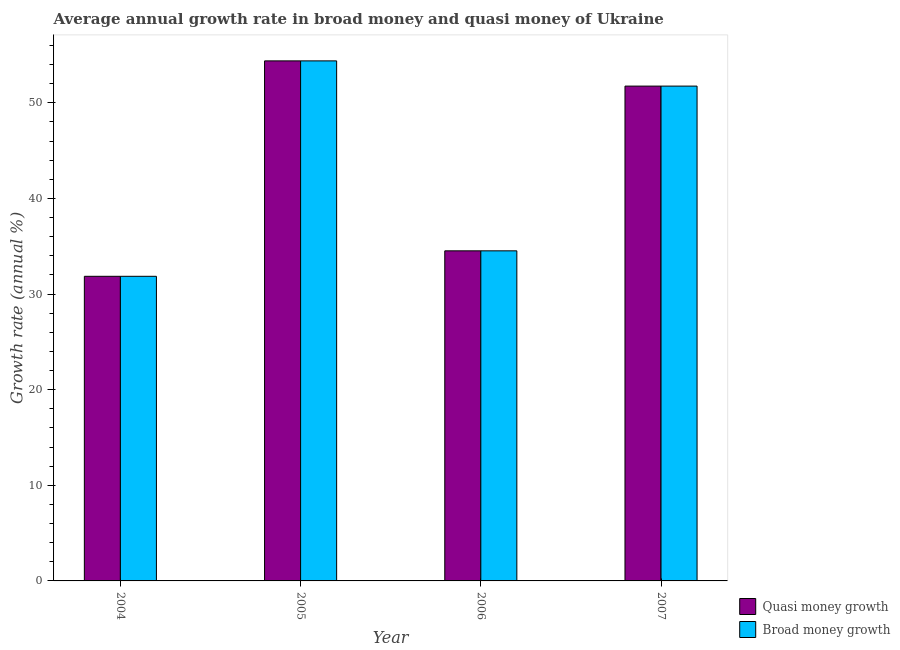How many different coloured bars are there?
Ensure brevity in your answer.  2. How many groups of bars are there?
Provide a short and direct response. 4. What is the label of the 1st group of bars from the left?
Offer a terse response. 2004. In how many cases, is the number of bars for a given year not equal to the number of legend labels?
Make the answer very short. 0. What is the annual growth rate in broad money in 2006?
Offer a terse response. 34.52. Across all years, what is the maximum annual growth rate in quasi money?
Make the answer very short. 54.39. Across all years, what is the minimum annual growth rate in quasi money?
Offer a terse response. 31.86. In which year was the annual growth rate in broad money maximum?
Keep it short and to the point. 2005. In which year was the annual growth rate in quasi money minimum?
Your response must be concise. 2004. What is the total annual growth rate in quasi money in the graph?
Make the answer very short. 172.51. What is the difference between the annual growth rate in broad money in 2005 and that in 2006?
Offer a very short reply. 19.87. What is the difference between the annual growth rate in quasi money in 2005 and the annual growth rate in broad money in 2006?
Offer a terse response. 19.87. What is the average annual growth rate in quasi money per year?
Offer a terse response. 43.13. In the year 2005, what is the difference between the annual growth rate in broad money and annual growth rate in quasi money?
Your answer should be compact. 0. In how many years, is the annual growth rate in broad money greater than 26 %?
Ensure brevity in your answer.  4. What is the ratio of the annual growth rate in broad money in 2005 to that in 2007?
Your answer should be very brief. 1.05. What is the difference between the highest and the second highest annual growth rate in quasi money?
Provide a short and direct response. 2.64. What is the difference between the highest and the lowest annual growth rate in quasi money?
Ensure brevity in your answer.  22.53. In how many years, is the annual growth rate in quasi money greater than the average annual growth rate in quasi money taken over all years?
Provide a short and direct response. 2. What does the 1st bar from the left in 2005 represents?
Make the answer very short. Quasi money growth. What does the 1st bar from the right in 2007 represents?
Offer a very short reply. Broad money growth. How many bars are there?
Your answer should be very brief. 8. Are all the bars in the graph horizontal?
Make the answer very short. No. How many years are there in the graph?
Provide a short and direct response. 4. Are the values on the major ticks of Y-axis written in scientific E-notation?
Provide a short and direct response. No. Where does the legend appear in the graph?
Make the answer very short. Bottom right. How are the legend labels stacked?
Keep it short and to the point. Vertical. What is the title of the graph?
Your answer should be very brief. Average annual growth rate in broad money and quasi money of Ukraine. Does "Transport services" appear as one of the legend labels in the graph?
Your response must be concise. No. What is the label or title of the Y-axis?
Your answer should be compact. Growth rate (annual %). What is the Growth rate (annual %) of Quasi money growth in 2004?
Offer a terse response. 31.86. What is the Growth rate (annual %) in Broad money growth in 2004?
Your answer should be very brief. 31.86. What is the Growth rate (annual %) of Quasi money growth in 2005?
Give a very brief answer. 54.39. What is the Growth rate (annual %) in Broad money growth in 2005?
Your answer should be very brief. 54.39. What is the Growth rate (annual %) in Quasi money growth in 2006?
Keep it short and to the point. 34.52. What is the Growth rate (annual %) of Broad money growth in 2006?
Give a very brief answer. 34.52. What is the Growth rate (annual %) of Quasi money growth in 2007?
Ensure brevity in your answer.  51.75. What is the Growth rate (annual %) in Broad money growth in 2007?
Offer a terse response. 51.75. Across all years, what is the maximum Growth rate (annual %) in Quasi money growth?
Your response must be concise. 54.39. Across all years, what is the maximum Growth rate (annual %) in Broad money growth?
Make the answer very short. 54.39. Across all years, what is the minimum Growth rate (annual %) in Quasi money growth?
Provide a succinct answer. 31.86. Across all years, what is the minimum Growth rate (annual %) of Broad money growth?
Offer a very short reply. 31.86. What is the total Growth rate (annual %) in Quasi money growth in the graph?
Your response must be concise. 172.51. What is the total Growth rate (annual %) of Broad money growth in the graph?
Offer a very short reply. 172.51. What is the difference between the Growth rate (annual %) in Quasi money growth in 2004 and that in 2005?
Your answer should be very brief. -22.53. What is the difference between the Growth rate (annual %) in Broad money growth in 2004 and that in 2005?
Your answer should be compact. -22.53. What is the difference between the Growth rate (annual %) in Quasi money growth in 2004 and that in 2006?
Provide a short and direct response. -2.66. What is the difference between the Growth rate (annual %) of Broad money growth in 2004 and that in 2006?
Ensure brevity in your answer.  -2.66. What is the difference between the Growth rate (annual %) in Quasi money growth in 2004 and that in 2007?
Ensure brevity in your answer.  -19.89. What is the difference between the Growth rate (annual %) of Broad money growth in 2004 and that in 2007?
Ensure brevity in your answer.  -19.89. What is the difference between the Growth rate (annual %) in Quasi money growth in 2005 and that in 2006?
Your answer should be compact. 19.87. What is the difference between the Growth rate (annual %) of Broad money growth in 2005 and that in 2006?
Provide a short and direct response. 19.87. What is the difference between the Growth rate (annual %) of Quasi money growth in 2005 and that in 2007?
Offer a terse response. 2.64. What is the difference between the Growth rate (annual %) in Broad money growth in 2005 and that in 2007?
Make the answer very short. 2.64. What is the difference between the Growth rate (annual %) of Quasi money growth in 2006 and that in 2007?
Offer a terse response. -17.23. What is the difference between the Growth rate (annual %) of Broad money growth in 2006 and that in 2007?
Your answer should be very brief. -17.23. What is the difference between the Growth rate (annual %) of Quasi money growth in 2004 and the Growth rate (annual %) of Broad money growth in 2005?
Give a very brief answer. -22.53. What is the difference between the Growth rate (annual %) of Quasi money growth in 2004 and the Growth rate (annual %) of Broad money growth in 2006?
Provide a succinct answer. -2.66. What is the difference between the Growth rate (annual %) of Quasi money growth in 2004 and the Growth rate (annual %) of Broad money growth in 2007?
Your answer should be very brief. -19.89. What is the difference between the Growth rate (annual %) of Quasi money growth in 2005 and the Growth rate (annual %) of Broad money growth in 2006?
Provide a succinct answer. 19.87. What is the difference between the Growth rate (annual %) in Quasi money growth in 2005 and the Growth rate (annual %) in Broad money growth in 2007?
Provide a short and direct response. 2.64. What is the difference between the Growth rate (annual %) in Quasi money growth in 2006 and the Growth rate (annual %) in Broad money growth in 2007?
Make the answer very short. -17.23. What is the average Growth rate (annual %) in Quasi money growth per year?
Provide a short and direct response. 43.13. What is the average Growth rate (annual %) in Broad money growth per year?
Your response must be concise. 43.13. In the year 2006, what is the difference between the Growth rate (annual %) of Quasi money growth and Growth rate (annual %) of Broad money growth?
Ensure brevity in your answer.  0. In the year 2007, what is the difference between the Growth rate (annual %) of Quasi money growth and Growth rate (annual %) of Broad money growth?
Your answer should be compact. 0. What is the ratio of the Growth rate (annual %) in Quasi money growth in 2004 to that in 2005?
Offer a very short reply. 0.59. What is the ratio of the Growth rate (annual %) of Broad money growth in 2004 to that in 2005?
Make the answer very short. 0.59. What is the ratio of the Growth rate (annual %) in Quasi money growth in 2004 to that in 2006?
Your response must be concise. 0.92. What is the ratio of the Growth rate (annual %) of Broad money growth in 2004 to that in 2006?
Keep it short and to the point. 0.92. What is the ratio of the Growth rate (annual %) of Quasi money growth in 2004 to that in 2007?
Give a very brief answer. 0.62. What is the ratio of the Growth rate (annual %) of Broad money growth in 2004 to that in 2007?
Offer a very short reply. 0.62. What is the ratio of the Growth rate (annual %) of Quasi money growth in 2005 to that in 2006?
Offer a very short reply. 1.58. What is the ratio of the Growth rate (annual %) in Broad money growth in 2005 to that in 2006?
Provide a succinct answer. 1.58. What is the ratio of the Growth rate (annual %) of Quasi money growth in 2005 to that in 2007?
Make the answer very short. 1.05. What is the ratio of the Growth rate (annual %) in Broad money growth in 2005 to that in 2007?
Your answer should be compact. 1.05. What is the ratio of the Growth rate (annual %) in Quasi money growth in 2006 to that in 2007?
Your response must be concise. 0.67. What is the ratio of the Growth rate (annual %) of Broad money growth in 2006 to that in 2007?
Give a very brief answer. 0.67. What is the difference between the highest and the second highest Growth rate (annual %) of Quasi money growth?
Make the answer very short. 2.64. What is the difference between the highest and the second highest Growth rate (annual %) of Broad money growth?
Provide a succinct answer. 2.64. What is the difference between the highest and the lowest Growth rate (annual %) of Quasi money growth?
Your response must be concise. 22.53. What is the difference between the highest and the lowest Growth rate (annual %) in Broad money growth?
Your answer should be very brief. 22.53. 